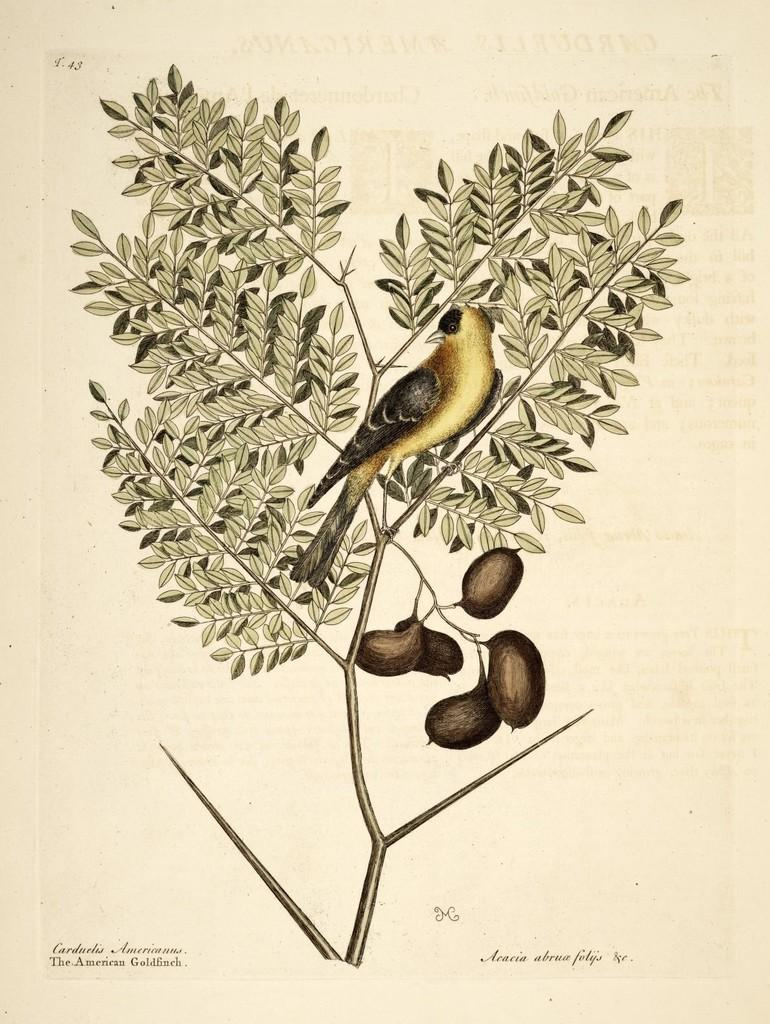What type of animal can be seen in the image? There is a bird in the image. What is the bird perched on or near in the image? The bird is near a plant that has leaves and fruits. What can be read at the bottom of the image? There is some text visible at the bottom of the image. What numbers are visible in the top left of the image? There are numbers visible in the top left of the image. What type of volcano can be seen erupting in the image? There is no volcano present in the image; it features a bird, a plant with leaves and fruits, text, and numbers. How many passengers are visible in the image? There are no passengers present in the image. 